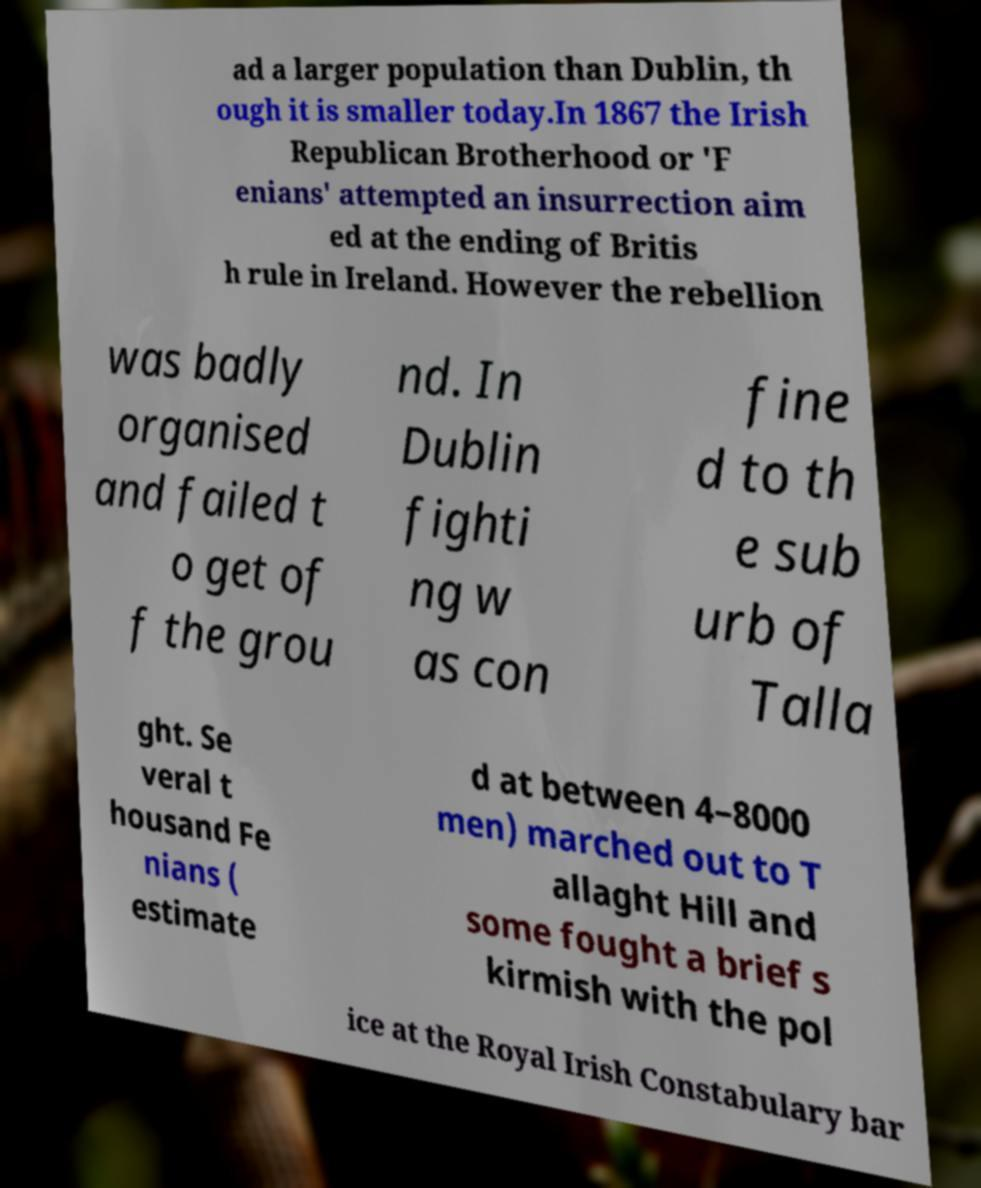For documentation purposes, I need the text within this image transcribed. Could you provide that? ad a larger population than Dublin, th ough it is smaller today.In 1867 the Irish Republican Brotherhood or 'F enians' attempted an insurrection aim ed at the ending of Britis h rule in Ireland. However the rebellion was badly organised and failed t o get of f the grou nd. In Dublin fighti ng w as con fine d to th e sub urb of Talla ght. Se veral t housand Fe nians ( estimate d at between 4–8000 men) marched out to T allaght Hill and some fought a brief s kirmish with the pol ice at the Royal Irish Constabulary bar 